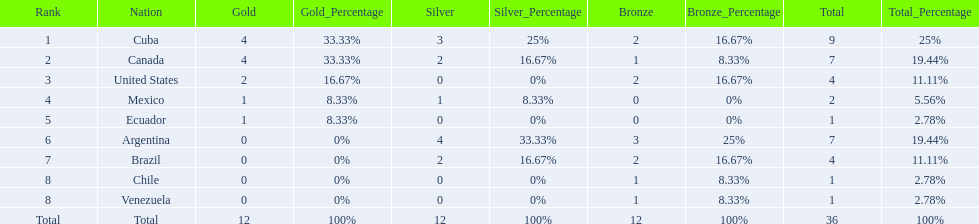How many total medals did brazil received? 4. 